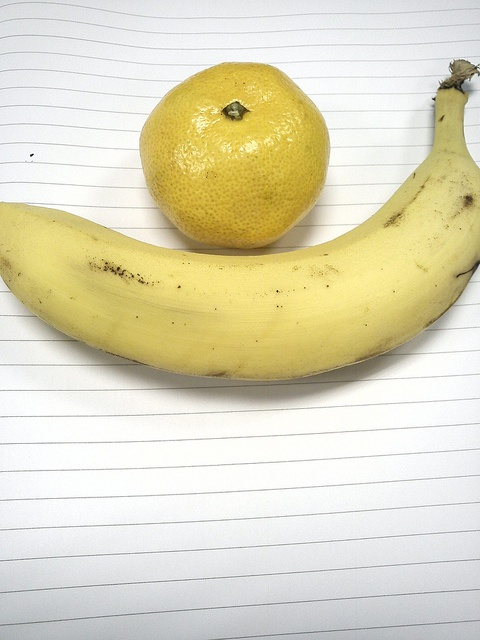Describe the objects in this image and their specific colors. I can see banana in lightgray, khaki, and tan tones and orange in lightgray, gold, and olive tones in this image. 